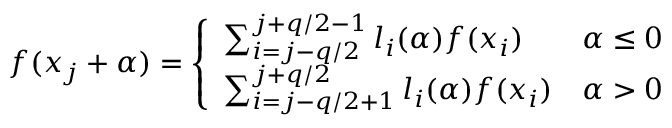Convert formula to latex. <formula><loc_0><loc_0><loc_500><loc_500>\begin{array} { r } { f ( x _ { j } + \alpha ) = \left \{ \begin{array} { l l } { \sum _ { i = j - q / 2 } ^ { j + q / 2 - 1 } l _ { i } ( \alpha ) f ( x _ { i } ) } & { \alpha \leq 0 } \\ { \sum _ { i = j - q / 2 + 1 } ^ { j + q / 2 } l _ { i } ( \alpha ) f ( x _ { i } ) } & { \alpha > 0 } \end{array} } \end{array}</formula> 